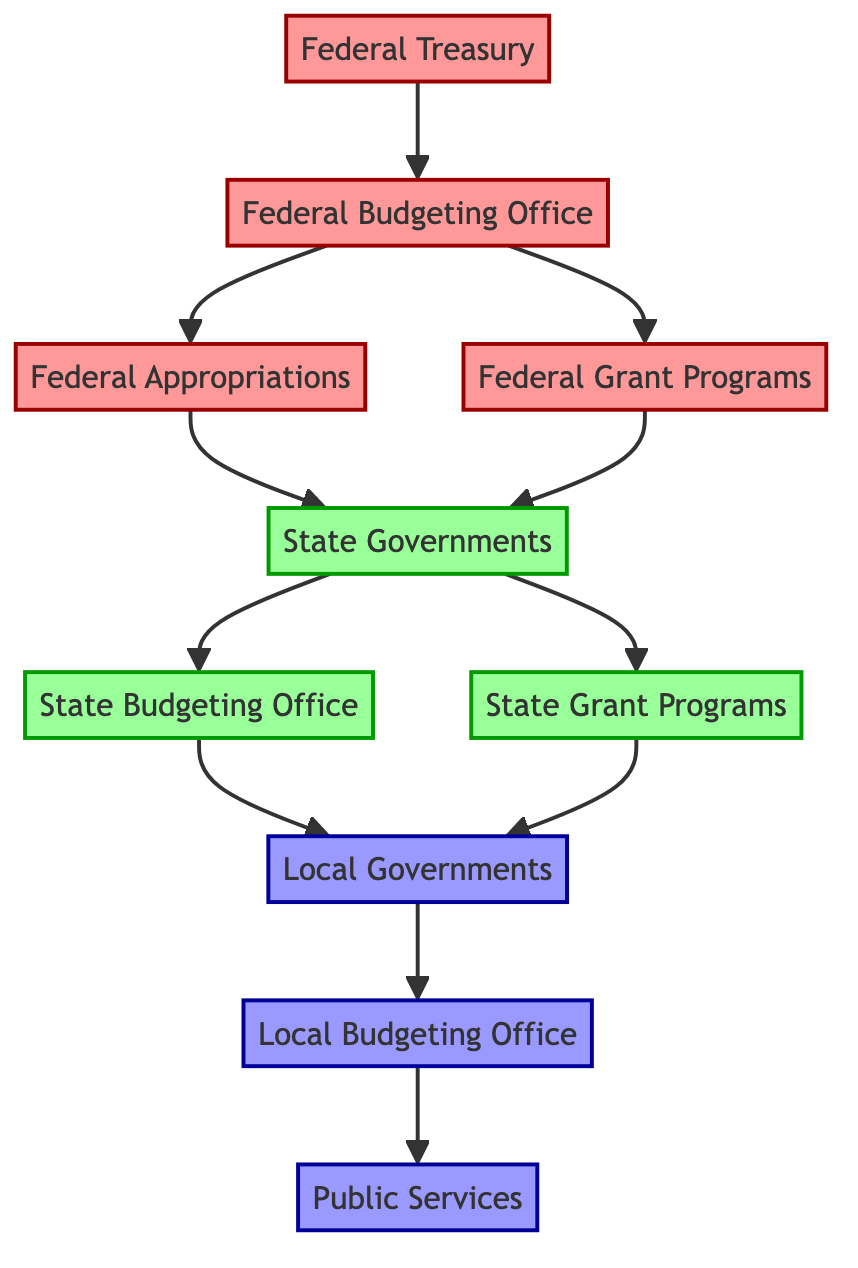What is the first node in the flow chart? The first node represents the starting point of the flow, which is the "Federal Treasury".
Answer: Federal Treasury How many levels of government are represented in the diagram? The diagram shows a total of four levels of government: Federal, State, and Local.
Answer: Three What is the relationship between the Federal Budgeting Office and the Federal Appropriations? The Federal Budgeting Office directs the flow to the Federal Appropriations as part of its responsibilities in budget formulation and execution.
Answer: Directs What node do State Governments send funds to? State Governments send funds to the Local Governments as part of the distribution process.
Answer: Local Governments Which node comes after State Grant Programs? The node that follows State Grant Programs in the flow is Local Governments.
Answer: Local Governments What types of services are ultimately provided at the final node? The final node illustrates the Public Services that are delivered to the community, such as education and healthcare.
Answer: Public Services Which office manages state-level budgets? The office responsible for managing state-level budgets is the State Budgeting Office.
Answer: State Budgeting Office What is the last step in the flow of public funds? The last step in the flow of public funds is the provision of Public Services to the citizens.
Answer: Public Services How do Federal Grant Programs relate to State Governments? Federal Grant Programs provide funding initiatives that support the financial needs of State Governments.
Answer: Provides funding What role does the Local Budgeting Office play at the local level? The Local Budgeting Office handles the planning and distribution of funds for local projects and services.
Answer: Handles budget planning 